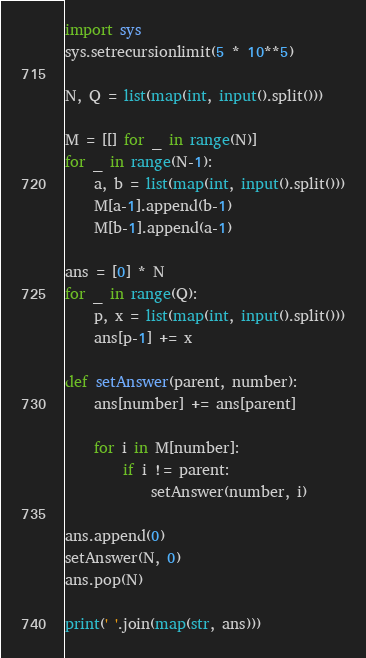Convert code to text. <code><loc_0><loc_0><loc_500><loc_500><_Python_>import sys
sys.setrecursionlimit(5 * 10**5)
 
N, Q = list(map(int, input().split()))
 
M = [[] for _ in range(N)]
for _ in range(N-1):
    a, b = list(map(int, input().split()))
    M[a-1].append(b-1)
    M[b-1].append(a-1)
 
ans = [0] * N
for _ in range(Q):
    p, x = list(map(int, input().split()))
    ans[p-1] += x
 
def setAnswer(parent, number):
    ans[number] += ans[parent]
 
    for i in M[number]:
        if i != parent:
            setAnswer(number, i)

ans.append(0)
setAnswer(N, 0)
ans.pop(N)
 
print(' '.join(map(str, ans)))
</code> 